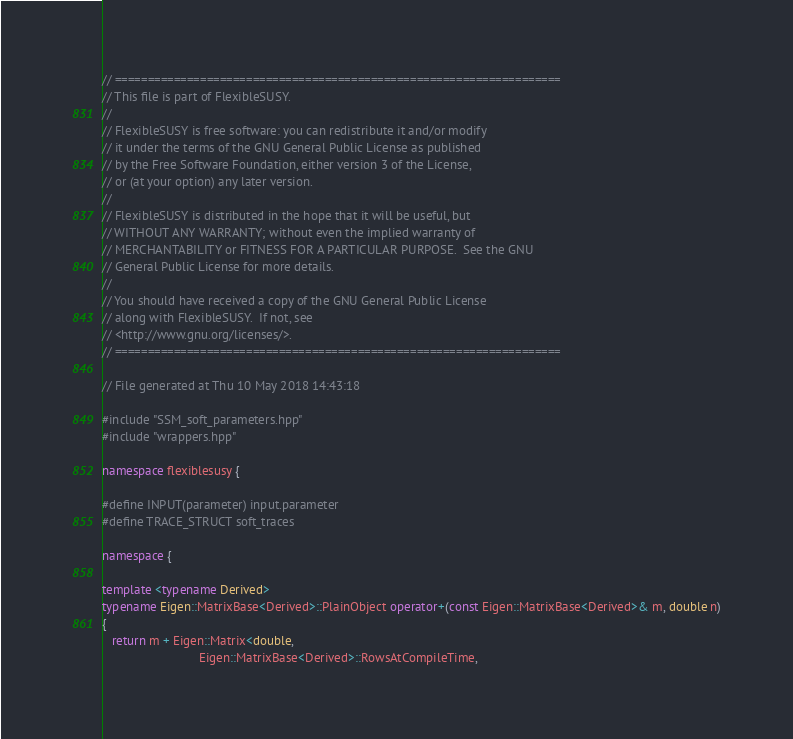Convert code to text. <code><loc_0><loc_0><loc_500><loc_500><_C++_>// ====================================================================
// This file is part of FlexibleSUSY.
//
// FlexibleSUSY is free software: you can redistribute it and/or modify
// it under the terms of the GNU General Public License as published
// by the Free Software Foundation, either version 3 of the License,
// or (at your option) any later version.
//
// FlexibleSUSY is distributed in the hope that it will be useful, but
// WITHOUT ANY WARRANTY; without even the implied warranty of
// MERCHANTABILITY or FITNESS FOR A PARTICULAR PURPOSE.  See the GNU
// General Public License for more details.
//
// You should have received a copy of the GNU General Public License
// along with FlexibleSUSY.  If not, see
// <http://www.gnu.org/licenses/>.
// ====================================================================

// File generated at Thu 10 May 2018 14:43:18

#include "SSM_soft_parameters.hpp"
#include "wrappers.hpp"

namespace flexiblesusy {

#define INPUT(parameter) input.parameter
#define TRACE_STRUCT soft_traces

namespace {

template <typename Derived>
typename Eigen::MatrixBase<Derived>::PlainObject operator+(const Eigen::MatrixBase<Derived>& m, double n)
{
   return m + Eigen::Matrix<double,
                            Eigen::MatrixBase<Derived>::RowsAtCompileTime,</code> 